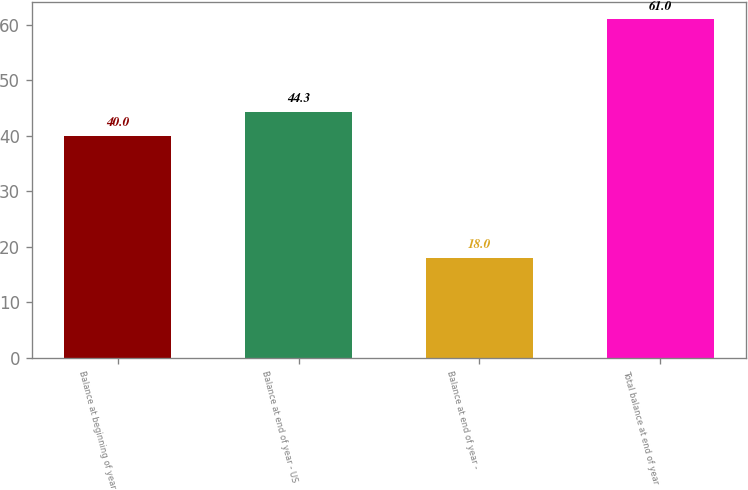<chart> <loc_0><loc_0><loc_500><loc_500><bar_chart><fcel>Balance at beginning of year<fcel>Balance at end of year - US<fcel>Balance at end of year -<fcel>Total balance at end of year<nl><fcel>40<fcel>44.3<fcel>18<fcel>61<nl></chart> 